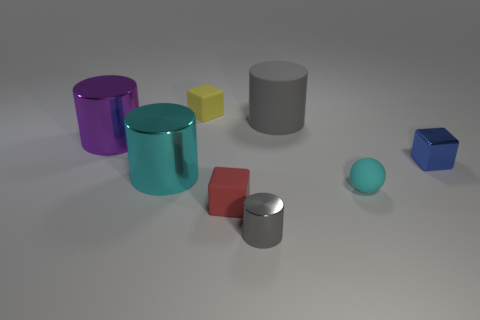Subtract all big rubber cylinders. How many cylinders are left? 3 Subtract all brown cylinders. Subtract all brown cubes. How many cylinders are left? 4 Subtract all green cylinders. How many yellow cubes are left? 1 Subtract all red blocks. How many blocks are left? 2 Subtract all cubes. How many objects are left? 5 Subtract 1 cubes. How many cubes are left? 2 Subtract all cyan cylinders. Subtract all tiny gray metallic blocks. How many objects are left? 7 Add 2 purple metal cylinders. How many purple metal cylinders are left? 3 Add 7 small yellow blocks. How many small yellow blocks exist? 8 Add 1 tiny gray metallic objects. How many objects exist? 9 